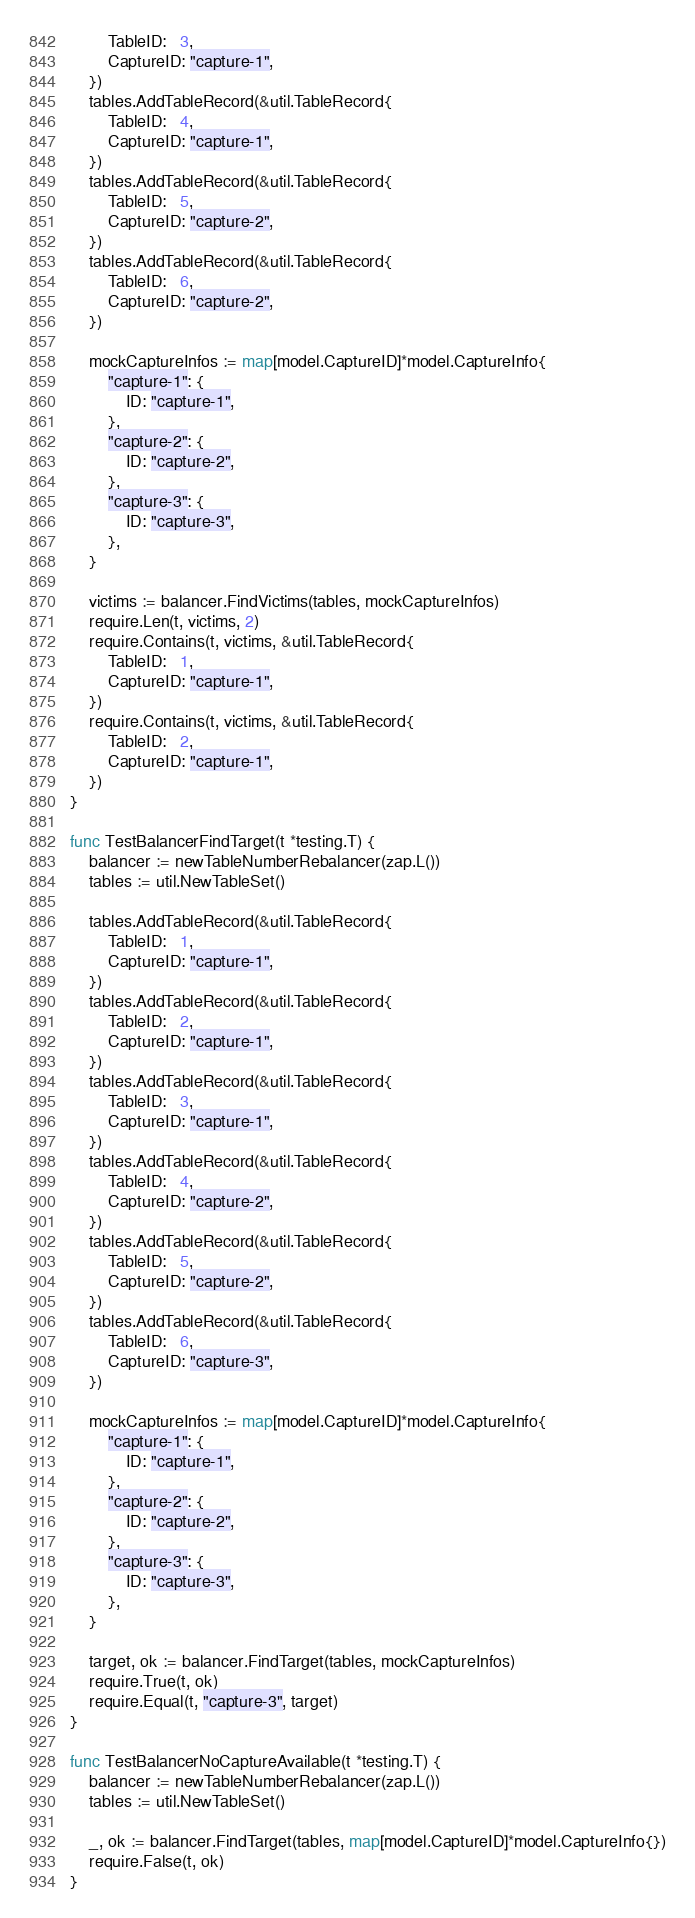Convert code to text. <code><loc_0><loc_0><loc_500><loc_500><_Go_>		TableID:   3,
		CaptureID: "capture-1",
	})
	tables.AddTableRecord(&util.TableRecord{
		TableID:   4,
		CaptureID: "capture-1",
	})
	tables.AddTableRecord(&util.TableRecord{
		TableID:   5,
		CaptureID: "capture-2",
	})
	tables.AddTableRecord(&util.TableRecord{
		TableID:   6,
		CaptureID: "capture-2",
	})

	mockCaptureInfos := map[model.CaptureID]*model.CaptureInfo{
		"capture-1": {
			ID: "capture-1",
		},
		"capture-2": {
			ID: "capture-2",
		},
		"capture-3": {
			ID: "capture-3",
		},
	}

	victims := balancer.FindVictims(tables, mockCaptureInfos)
	require.Len(t, victims, 2)
	require.Contains(t, victims, &util.TableRecord{
		TableID:   1,
		CaptureID: "capture-1",
	})
	require.Contains(t, victims, &util.TableRecord{
		TableID:   2,
		CaptureID: "capture-1",
	})
}

func TestBalancerFindTarget(t *testing.T) {
	balancer := newTableNumberRebalancer(zap.L())
	tables := util.NewTableSet()

	tables.AddTableRecord(&util.TableRecord{
		TableID:   1,
		CaptureID: "capture-1",
	})
	tables.AddTableRecord(&util.TableRecord{
		TableID:   2,
		CaptureID: "capture-1",
	})
	tables.AddTableRecord(&util.TableRecord{
		TableID:   3,
		CaptureID: "capture-1",
	})
	tables.AddTableRecord(&util.TableRecord{
		TableID:   4,
		CaptureID: "capture-2",
	})
	tables.AddTableRecord(&util.TableRecord{
		TableID:   5,
		CaptureID: "capture-2",
	})
	tables.AddTableRecord(&util.TableRecord{
		TableID:   6,
		CaptureID: "capture-3",
	})

	mockCaptureInfos := map[model.CaptureID]*model.CaptureInfo{
		"capture-1": {
			ID: "capture-1",
		},
		"capture-2": {
			ID: "capture-2",
		},
		"capture-3": {
			ID: "capture-3",
		},
	}

	target, ok := balancer.FindTarget(tables, mockCaptureInfos)
	require.True(t, ok)
	require.Equal(t, "capture-3", target)
}

func TestBalancerNoCaptureAvailable(t *testing.T) {
	balancer := newTableNumberRebalancer(zap.L())
	tables := util.NewTableSet()

	_, ok := balancer.FindTarget(tables, map[model.CaptureID]*model.CaptureInfo{})
	require.False(t, ok)
}
</code> 